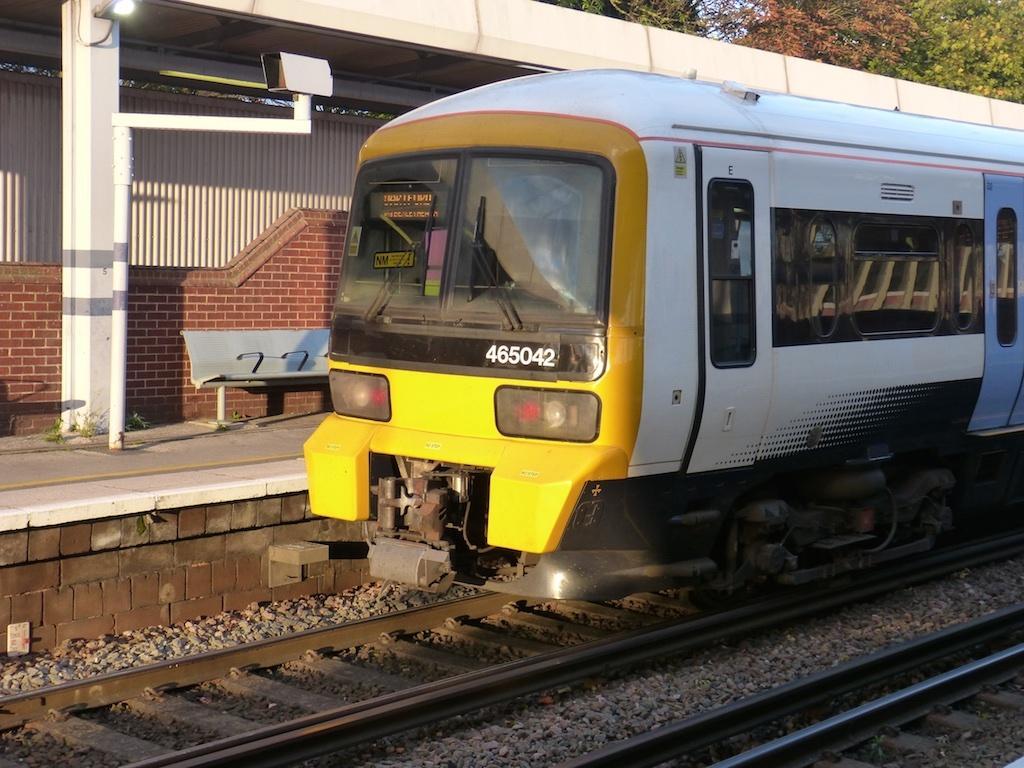How would you summarize this image in a sentence or two? In this image we can see a train on the railway track. In the background we can see sky, trees, plants, electric light, benches and a platform. 